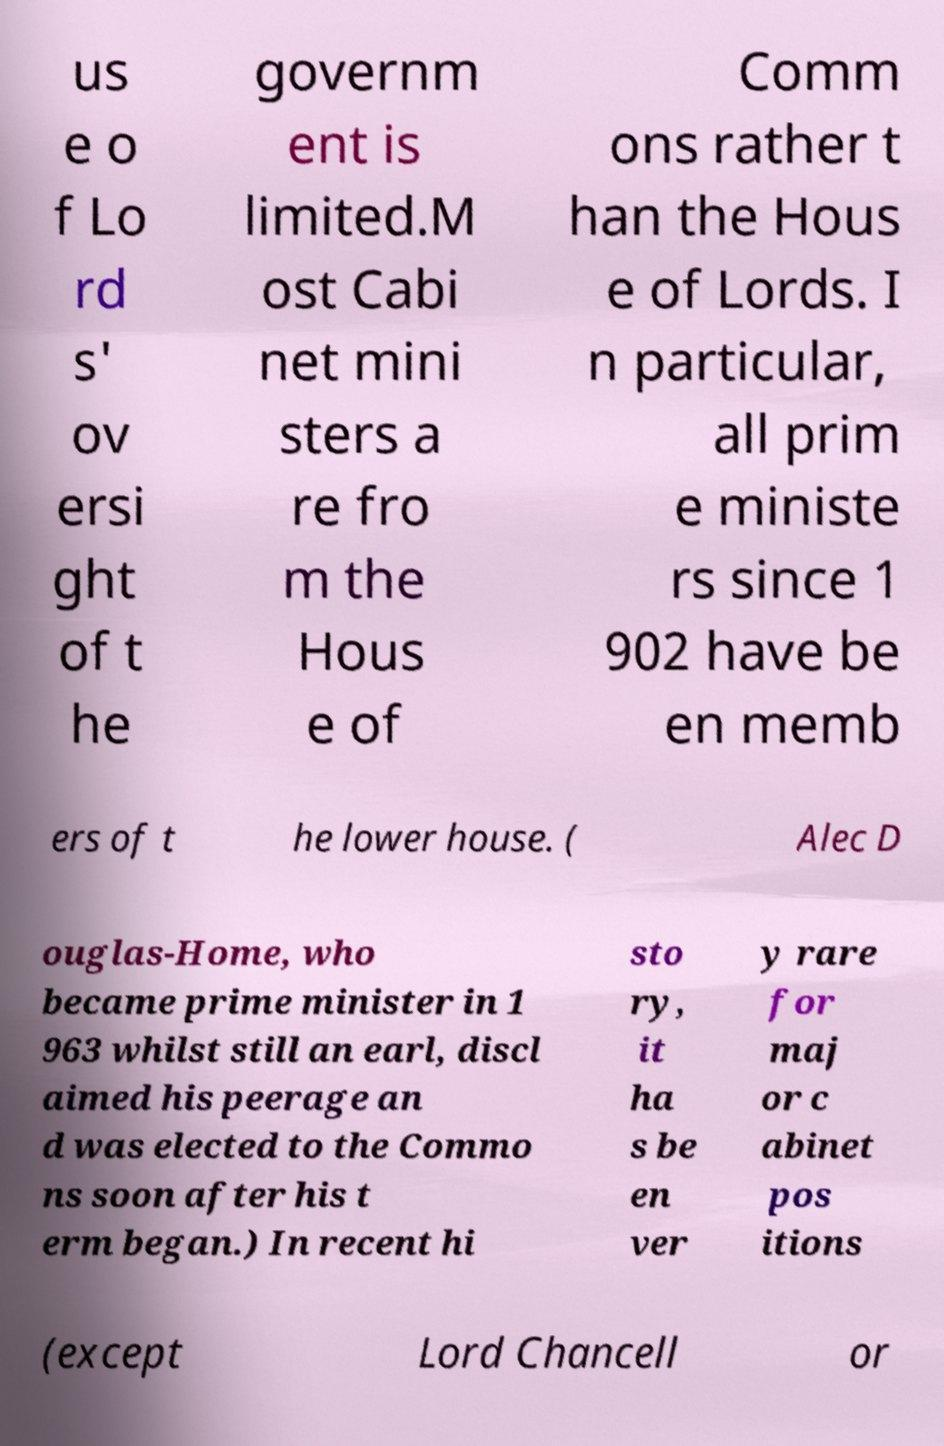I need the written content from this picture converted into text. Can you do that? us e o f Lo rd s' ov ersi ght of t he governm ent is limited.M ost Cabi net mini sters a re fro m the Hous e of Comm ons rather t han the Hous e of Lords. I n particular, all prim e ministe rs since 1 902 have be en memb ers of t he lower house. ( Alec D ouglas-Home, who became prime minister in 1 963 whilst still an earl, discl aimed his peerage an d was elected to the Commo ns soon after his t erm began.) In recent hi sto ry, it ha s be en ver y rare for maj or c abinet pos itions (except Lord Chancell or 